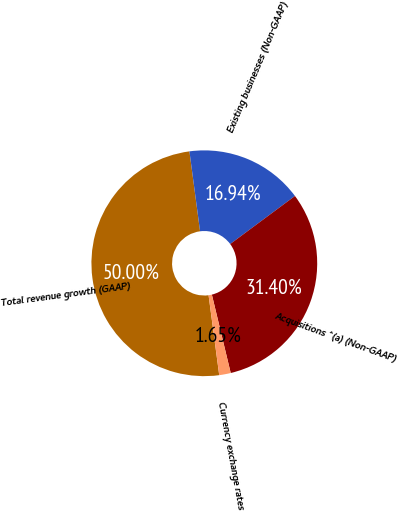Convert chart. <chart><loc_0><loc_0><loc_500><loc_500><pie_chart><fcel>Total revenue growth (GAAP)<fcel>Existing businesses (Non-GAAP)<fcel>Acquisitions ^(a) (Non-GAAP)<fcel>Currency exchange rates<nl><fcel>50.0%<fcel>16.94%<fcel>31.4%<fcel>1.65%<nl></chart> 